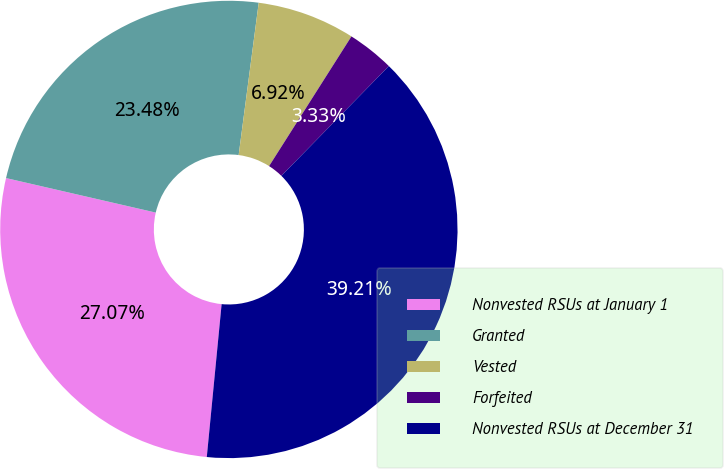<chart> <loc_0><loc_0><loc_500><loc_500><pie_chart><fcel>Nonvested RSUs at January 1<fcel>Granted<fcel>Vested<fcel>Forfeited<fcel>Nonvested RSUs at December 31<nl><fcel>27.07%<fcel>23.48%<fcel>6.92%<fcel>3.33%<fcel>39.21%<nl></chart> 